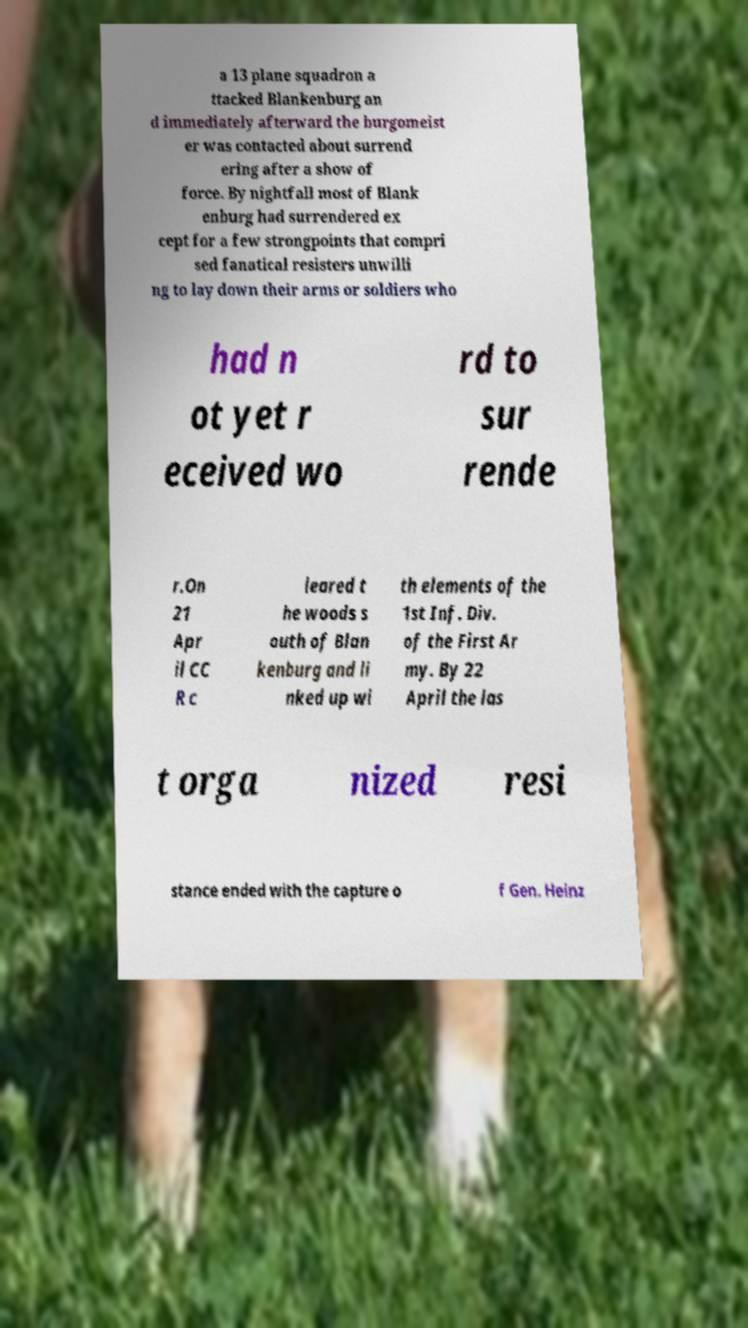For documentation purposes, I need the text within this image transcribed. Could you provide that? a 13 plane squadron a ttacked Blankenburg an d immediately afterward the burgomeist er was contacted about surrend ering after a show of force. By nightfall most of Blank enburg had surrendered ex cept for a few strongpoints that compri sed fanatical resisters unwilli ng to lay down their arms or soldiers who had n ot yet r eceived wo rd to sur rende r.On 21 Apr il CC R c leared t he woods s outh of Blan kenburg and li nked up wi th elements of the 1st Inf. Div. of the First Ar my. By 22 April the las t orga nized resi stance ended with the capture o f Gen. Heinz 